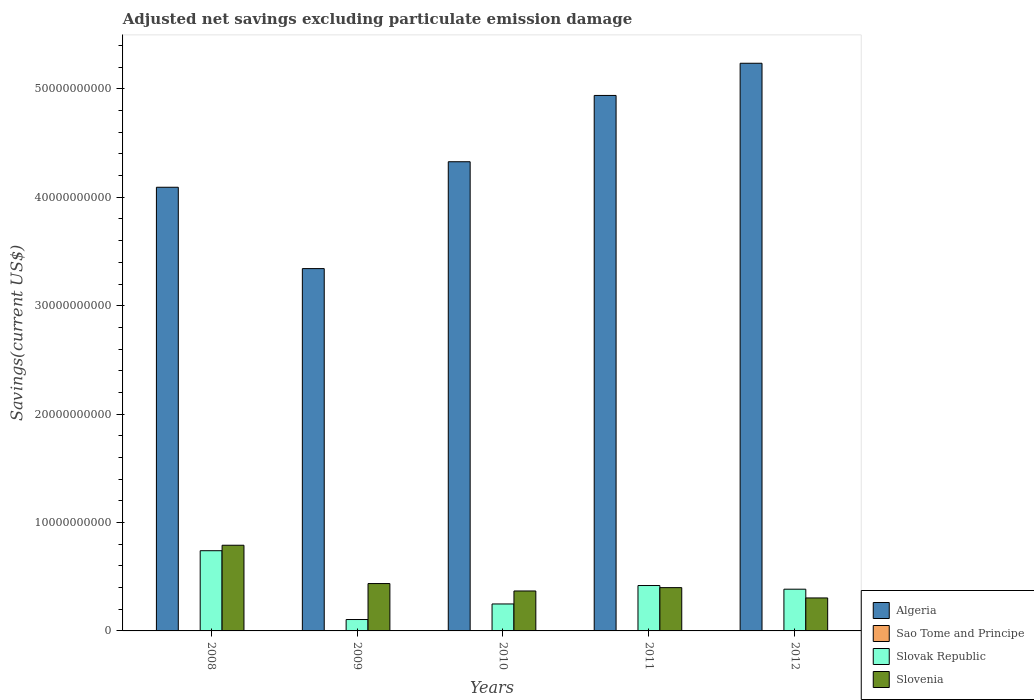Are the number of bars on each tick of the X-axis equal?
Offer a very short reply. No. How many bars are there on the 2nd tick from the left?
Ensure brevity in your answer.  4. What is the label of the 5th group of bars from the left?
Offer a terse response. 2012. In how many cases, is the number of bars for a given year not equal to the number of legend labels?
Your answer should be compact. 2. What is the adjusted net savings in Algeria in 2011?
Your answer should be compact. 4.94e+1. Across all years, what is the maximum adjusted net savings in Slovak Republic?
Offer a very short reply. 7.40e+09. Across all years, what is the minimum adjusted net savings in Slovak Republic?
Offer a terse response. 1.05e+09. What is the total adjusted net savings in Slovak Republic in the graph?
Your answer should be compact. 1.90e+1. What is the difference between the adjusted net savings in Slovenia in 2009 and that in 2012?
Provide a short and direct response. 1.33e+09. What is the difference between the adjusted net savings in Sao Tome and Principe in 2011 and the adjusted net savings in Slovak Republic in 2012?
Make the answer very short. -3.85e+09. What is the average adjusted net savings in Slovenia per year?
Make the answer very short. 4.60e+09. In the year 2008, what is the difference between the adjusted net savings in Slovenia and adjusted net savings in Slovak Republic?
Make the answer very short. 5.06e+08. What is the ratio of the adjusted net savings in Slovak Republic in 2011 to that in 2012?
Offer a very short reply. 1.09. Is the adjusted net savings in Algeria in 2008 less than that in 2010?
Keep it short and to the point. Yes. Is the difference between the adjusted net savings in Slovenia in 2008 and 2010 greater than the difference between the adjusted net savings in Slovak Republic in 2008 and 2010?
Provide a short and direct response. No. What is the difference between the highest and the second highest adjusted net savings in Slovak Republic?
Give a very brief answer. 3.21e+09. What is the difference between the highest and the lowest adjusted net savings in Algeria?
Your answer should be compact. 1.89e+1. Is the sum of the adjusted net savings in Slovak Republic in 2009 and 2011 greater than the maximum adjusted net savings in Sao Tome and Principe across all years?
Your answer should be compact. Yes. Is it the case that in every year, the sum of the adjusted net savings in Slovenia and adjusted net savings in Algeria is greater than the sum of adjusted net savings in Slovak Republic and adjusted net savings in Sao Tome and Principe?
Provide a short and direct response. Yes. Are all the bars in the graph horizontal?
Your answer should be compact. No. How many years are there in the graph?
Give a very brief answer. 5. Are the values on the major ticks of Y-axis written in scientific E-notation?
Keep it short and to the point. No. Does the graph contain any zero values?
Keep it short and to the point. Yes. Does the graph contain grids?
Make the answer very short. No. Where does the legend appear in the graph?
Provide a succinct answer. Bottom right. How many legend labels are there?
Offer a terse response. 4. What is the title of the graph?
Your answer should be very brief. Adjusted net savings excluding particulate emission damage. What is the label or title of the Y-axis?
Offer a very short reply. Savings(current US$). What is the Savings(current US$) of Algeria in 2008?
Make the answer very short. 4.09e+1. What is the Savings(current US$) of Slovak Republic in 2008?
Provide a short and direct response. 7.40e+09. What is the Savings(current US$) of Slovenia in 2008?
Your response must be concise. 7.90e+09. What is the Savings(current US$) in Algeria in 2009?
Offer a very short reply. 3.34e+1. What is the Savings(current US$) in Sao Tome and Principe in 2009?
Offer a terse response. 3.99e+05. What is the Savings(current US$) of Slovak Republic in 2009?
Make the answer very short. 1.05e+09. What is the Savings(current US$) of Slovenia in 2009?
Your answer should be very brief. 4.37e+09. What is the Savings(current US$) of Algeria in 2010?
Keep it short and to the point. 4.33e+1. What is the Savings(current US$) of Slovak Republic in 2010?
Offer a terse response. 2.49e+09. What is the Savings(current US$) of Slovenia in 2010?
Your answer should be compact. 3.69e+09. What is the Savings(current US$) in Algeria in 2011?
Offer a terse response. 4.94e+1. What is the Savings(current US$) in Sao Tome and Principe in 2011?
Offer a terse response. 6.00e+04. What is the Savings(current US$) of Slovak Republic in 2011?
Make the answer very short. 4.19e+09. What is the Savings(current US$) in Slovenia in 2011?
Your answer should be very brief. 3.99e+09. What is the Savings(current US$) in Algeria in 2012?
Your response must be concise. 5.24e+1. What is the Savings(current US$) in Sao Tome and Principe in 2012?
Ensure brevity in your answer.  1.08e+07. What is the Savings(current US$) of Slovak Republic in 2012?
Your answer should be very brief. 3.85e+09. What is the Savings(current US$) in Slovenia in 2012?
Offer a very short reply. 3.04e+09. Across all years, what is the maximum Savings(current US$) in Algeria?
Offer a very short reply. 5.24e+1. Across all years, what is the maximum Savings(current US$) of Sao Tome and Principe?
Offer a very short reply. 1.08e+07. Across all years, what is the maximum Savings(current US$) of Slovak Republic?
Make the answer very short. 7.40e+09. Across all years, what is the maximum Savings(current US$) of Slovenia?
Your response must be concise. 7.90e+09. Across all years, what is the minimum Savings(current US$) of Algeria?
Offer a terse response. 3.34e+1. Across all years, what is the minimum Savings(current US$) in Sao Tome and Principe?
Provide a short and direct response. 0. Across all years, what is the minimum Savings(current US$) in Slovak Republic?
Keep it short and to the point. 1.05e+09. Across all years, what is the minimum Savings(current US$) in Slovenia?
Your answer should be very brief. 3.04e+09. What is the total Savings(current US$) in Algeria in the graph?
Keep it short and to the point. 2.19e+11. What is the total Savings(current US$) of Sao Tome and Principe in the graph?
Your response must be concise. 1.13e+07. What is the total Savings(current US$) of Slovak Republic in the graph?
Your answer should be compact. 1.90e+1. What is the total Savings(current US$) of Slovenia in the graph?
Offer a very short reply. 2.30e+1. What is the difference between the Savings(current US$) in Algeria in 2008 and that in 2009?
Offer a terse response. 7.50e+09. What is the difference between the Savings(current US$) in Slovak Republic in 2008 and that in 2009?
Your answer should be very brief. 6.35e+09. What is the difference between the Savings(current US$) in Slovenia in 2008 and that in 2009?
Give a very brief answer. 3.53e+09. What is the difference between the Savings(current US$) in Algeria in 2008 and that in 2010?
Provide a succinct answer. -2.35e+09. What is the difference between the Savings(current US$) in Slovak Republic in 2008 and that in 2010?
Give a very brief answer. 4.91e+09. What is the difference between the Savings(current US$) in Slovenia in 2008 and that in 2010?
Keep it short and to the point. 4.22e+09. What is the difference between the Savings(current US$) in Algeria in 2008 and that in 2011?
Make the answer very short. -8.47e+09. What is the difference between the Savings(current US$) in Slovak Republic in 2008 and that in 2011?
Your answer should be compact. 3.21e+09. What is the difference between the Savings(current US$) of Slovenia in 2008 and that in 2011?
Give a very brief answer. 3.91e+09. What is the difference between the Savings(current US$) of Algeria in 2008 and that in 2012?
Offer a very short reply. -1.14e+1. What is the difference between the Savings(current US$) in Slovak Republic in 2008 and that in 2012?
Ensure brevity in your answer.  3.55e+09. What is the difference between the Savings(current US$) of Slovenia in 2008 and that in 2012?
Make the answer very short. 4.86e+09. What is the difference between the Savings(current US$) in Algeria in 2009 and that in 2010?
Ensure brevity in your answer.  -9.86e+09. What is the difference between the Savings(current US$) of Slovak Republic in 2009 and that in 2010?
Offer a terse response. -1.44e+09. What is the difference between the Savings(current US$) in Slovenia in 2009 and that in 2010?
Your response must be concise. 6.84e+08. What is the difference between the Savings(current US$) of Algeria in 2009 and that in 2011?
Keep it short and to the point. -1.60e+1. What is the difference between the Savings(current US$) in Sao Tome and Principe in 2009 and that in 2011?
Ensure brevity in your answer.  3.39e+05. What is the difference between the Savings(current US$) of Slovak Republic in 2009 and that in 2011?
Your response must be concise. -3.13e+09. What is the difference between the Savings(current US$) in Slovenia in 2009 and that in 2011?
Your answer should be compact. 3.77e+08. What is the difference between the Savings(current US$) of Algeria in 2009 and that in 2012?
Provide a short and direct response. -1.89e+1. What is the difference between the Savings(current US$) in Sao Tome and Principe in 2009 and that in 2012?
Your answer should be compact. -1.04e+07. What is the difference between the Savings(current US$) in Slovak Republic in 2009 and that in 2012?
Offer a terse response. -2.80e+09. What is the difference between the Savings(current US$) in Slovenia in 2009 and that in 2012?
Offer a terse response. 1.33e+09. What is the difference between the Savings(current US$) in Algeria in 2010 and that in 2011?
Ensure brevity in your answer.  -6.11e+09. What is the difference between the Savings(current US$) in Slovak Republic in 2010 and that in 2011?
Offer a terse response. -1.70e+09. What is the difference between the Savings(current US$) of Slovenia in 2010 and that in 2011?
Your response must be concise. -3.07e+08. What is the difference between the Savings(current US$) of Algeria in 2010 and that in 2012?
Make the answer very short. -9.08e+09. What is the difference between the Savings(current US$) in Slovak Republic in 2010 and that in 2012?
Keep it short and to the point. -1.36e+09. What is the difference between the Savings(current US$) of Slovenia in 2010 and that in 2012?
Give a very brief answer. 6.44e+08. What is the difference between the Savings(current US$) of Algeria in 2011 and that in 2012?
Provide a succinct answer. -2.97e+09. What is the difference between the Savings(current US$) in Sao Tome and Principe in 2011 and that in 2012?
Keep it short and to the point. -1.08e+07. What is the difference between the Savings(current US$) in Slovak Republic in 2011 and that in 2012?
Provide a succinct answer. 3.38e+08. What is the difference between the Savings(current US$) in Slovenia in 2011 and that in 2012?
Provide a succinct answer. 9.51e+08. What is the difference between the Savings(current US$) in Algeria in 2008 and the Savings(current US$) in Sao Tome and Principe in 2009?
Keep it short and to the point. 4.09e+1. What is the difference between the Savings(current US$) in Algeria in 2008 and the Savings(current US$) in Slovak Republic in 2009?
Ensure brevity in your answer.  3.99e+1. What is the difference between the Savings(current US$) in Algeria in 2008 and the Savings(current US$) in Slovenia in 2009?
Your answer should be very brief. 3.66e+1. What is the difference between the Savings(current US$) in Slovak Republic in 2008 and the Savings(current US$) in Slovenia in 2009?
Ensure brevity in your answer.  3.03e+09. What is the difference between the Savings(current US$) in Algeria in 2008 and the Savings(current US$) in Slovak Republic in 2010?
Your answer should be very brief. 3.84e+1. What is the difference between the Savings(current US$) of Algeria in 2008 and the Savings(current US$) of Slovenia in 2010?
Keep it short and to the point. 3.72e+1. What is the difference between the Savings(current US$) in Slovak Republic in 2008 and the Savings(current US$) in Slovenia in 2010?
Your answer should be compact. 3.71e+09. What is the difference between the Savings(current US$) in Algeria in 2008 and the Savings(current US$) in Sao Tome and Principe in 2011?
Make the answer very short. 4.09e+1. What is the difference between the Savings(current US$) in Algeria in 2008 and the Savings(current US$) in Slovak Republic in 2011?
Keep it short and to the point. 3.67e+1. What is the difference between the Savings(current US$) in Algeria in 2008 and the Savings(current US$) in Slovenia in 2011?
Provide a succinct answer. 3.69e+1. What is the difference between the Savings(current US$) of Slovak Republic in 2008 and the Savings(current US$) of Slovenia in 2011?
Provide a short and direct response. 3.41e+09. What is the difference between the Savings(current US$) in Algeria in 2008 and the Savings(current US$) in Sao Tome and Principe in 2012?
Offer a very short reply. 4.09e+1. What is the difference between the Savings(current US$) of Algeria in 2008 and the Savings(current US$) of Slovak Republic in 2012?
Your answer should be compact. 3.71e+1. What is the difference between the Savings(current US$) in Algeria in 2008 and the Savings(current US$) in Slovenia in 2012?
Your response must be concise. 3.79e+1. What is the difference between the Savings(current US$) of Slovak Republic in 2008 and the Savings(current US$) of Slovenia in 2012?
Offer a very short reply. 4.36e+09. What is the difference between the Savings(current US$) of Algeria in 2009 and the Savings(current US$) of Slovak Republic in 2010?
Provide a short and direct response. 3.09e+1. What is the difference between the Savings(current US$) in Algeria in 2009 and the Savings(current US$) in Slovenia in 2010?
Offer a very short reply. 2.97e+1. What is the difference between the Savings(current US$) of Sao Tome and Principe in 2009 and the Savings(current US$) of Slovak Republic in 2010?
Offer a terse response. -2.49e+09. What is the difference between the Savings(current US$) of Sao Tome and Principe in 2009 and the Savings(current US$) of Slovenia in 2010?
Offer a very short reply. -3.68e+09. What is the difference between the Savings(current US$) of Slovak Republic in 2009 and the Savings(current US$) of Slovenia in 2010?
Make the answer very short. -2.63e+09. What is the difference between the Savings(current US$) of Algeria in 2009 and the Savings(current US$) of Sao Tome and Principe in 2011?
Your answer should be very brief. 3.34e+1. What is the difference between the Savings(current US$) of Algeria in 2009 and the Savings(current US$) of Slovak Republic in 2011?
Make the answer very short. 2.92e+1. What is the difference between the Savings(current US$) in Algeria in 2009 and the Savings(current US$) in Slovenia in 2011?
Provide a succinct answer. 2.94e+1. What is the difference between the Savings(current US$) in Sao Tome and Principe in 2009 and the Savings(current US$) in Slovak Republic in 2011?
Offer a very short reply. -4.19e+09. What is the difference between the Savings(current US$) of Sao Tome and Principe in 2009 and the Savings(current US$) of Slovenia in 2011?
Your answer should be compact. -3.99e+09. What is the difference between the Savings(current US$) of Slovak Republic in 2009 and the Savings(current US$) of Slovenia in 2011?
Keep it short and to the point. -2.94e+09. What is the difference between the Savings(current US$) in Algeria in 2009 and the Savings(current US$) in Sao Tome and Principe in 2012?
Provide a succinct answer. 3.34e+1. What is the difference between the Savings(current US$) of Algeria in 2009 and the Savings(current US$) of Slovak Republic in 2012?
Keep it short and to the point. 2.96e+1. What is the difference between the Savings(current US$) of Algeria in 2009 and the Savings(current US$) of Slovenia in 2012?
Your response must be concise. 3.04e+1. What is the difference between the Savings(current US$) of Sao Tome and Principe in 2009 and the Savings(current US$) of Slovak Republic in 2012?
Your answer should be very brief. -3.85e+09. What is the difference between the Savings(current US$) in Sao Tome and Principe in 2009 and the Savings(current US$) in Slovenia in 2012?
Provide a succinct answer. -3.04e+09. What is the difference between the Savings(current US$) of Slovak Republic in 2009 and the Savings(current US$) of Slovenia in 2012?
Offer a terse response. -1.99e+09. What is the difference between the Savings(current US$) in Algeria in 2010 and the Savings(current US$) in Sao Tome and Principe in 2011?
Provide a succinct answer. 4.33e+1. What is the difference between the Savings(current US$) of Algeria in 2010 and the Savings(current US$) of Slovak Republic in 2011?
Offer a terse response. 3.91e+1. What is the difference between the Savings(current US$) of Algeria in 2010 and the Savings(current US$) of Slovenia in 2011?
Give a very brief answer. 3.93e+1. What is the difference between the Savings(current US$) in Slovak Republic in 2010 and the Savings(current US$) in Slovenia in 2011?
Provide a short and direct response. -1.51e+09. What is the difference between the Savings(current US$) in Algeria in 2010 and the Savings(current US$) in Sao Tome and Principe in 2012?
Ensure brevity in your answer.  4.33e+1. What is the difference between the Savings(current US$) in Algeria in 2010 and the Savings(current US$) in Slovak Republic in 2012?
Your answer should be compact. 3.94e+1. What is the difference between the Savings(current US$) in Algeria in 2010 and the Savings(current US$) in Slovenia in 2012?
Your answer should be compact. 4.02e+1. What is the difference between the Savings(current US$) of Slovak Republic in 2010 and the Savings(current US$) of Slovenia in 2012?
Make the answer very short. -5.54e+08. What is the difference between the Savings(current US$) in Algeria in 2011 and the Savings(current US$) in Sao Tome and Principe in 2012?
Ensure brevity in your answer.  4.94e+1. What is the difference between the Savings(current US$) in Algeria in 2011 and the Savings(current US$) in Slovak Republic in 2012?
Your answer should be very brief. 4.55e+1. What is the difference between the Savings(current US$) of Algeria in 2011 and the Savings(current US$) of Slovenia in 2012?
Make the answer very short. 4.64e+1. What is the difference between the Savings(current US$) of Sao Tome and Principe in 2011 and the Savings(current US$) of Slovak Republic in 2012?
Provide a short and direct response. -3.85e+09. What is the difference between the Savings(current US$) of Sao Tome and Principe in 2011 and the Savings(current US$) of Slovenia in 2012?
Your answer should be compact. -3.04e+09. What is the difference between the Savings(current US$) in Slovak Republic in 2011 and the Savings(current US$) in Slovenia in 2012?
Provide a succinct answer. 1.15e+09. What is the average Savings(current US$) of Algeria per year?
Keep it short and to the point. 4.39e+1. What is the average Savings(current US$) in Sao Tome and Principe per year?
Offer a terse response. 2.26e+06. What is the average Savings(current US$) of Slovak Republic per year?
Offer a very short reply. 3.79e+09. What is the average Savings(current US$) of Slovenia per year?
Offer a very short reply. 4.60e+09. In the year 2008, what is the difference between the Savings(current US$) of Algeria and Savings(current US$) of Slovak Republic?
Provide a short and direct response. 3.35e+1. In the year 2008, what is the difference between the Savings(current US$) of Algeria and Savings(current US$) of Slovenia?
Ensure brevity in your answer.  3.30e+1. In the year 2008, what is the difference between the Savings(current US$) in Slovak Republic and Savings(current US$) in Slovenia?
Your answer should be compact. -5.06e+08. In the year 2009, what is the difference between the Savings(current US$) in Algeria and Savings(current US$) in Sao Tome and Principe?
Your response must be concise. 3.34e+1. In the year 2009, what is the difference between the Savings(current US$) of Algeria and Savings(current US$) of Slovak Republic?
Provide a succinct answer. 3.24e+1. In the year 2009, what is the difference between the Savings(current US$) in Algeria and Savings(current US$) in Slovenia?
Provide a succinct answer. 2.91e+1. In the year 2009, what is the difference between the Savings(current US$) in Sao Tome and Principe and Savings(current US$) in Slovak Republic?
Make the answer very short. -1.05e+09. In the year 2009, what is the difference between the Savings(current US$) of Sao Tome and Principe and Savings(current US$) of Slovenia?
Offer a very short reply. -4.37e+09. In the year 2009, what is the difference between the Savings(current US$) of Slovak Republic and Savings(current US$) of Slovenia?
Offer a very short reply. -3.32e+09. In the year 2010, what is the difference between the Savings(current US$) in Algeria and Savings(current US$) in Slovak Republic?
Provide a succinct answer. 4.08e+1. In the year 2010, what is the difference between the Savings(current US$) in Algeria and Savings(current US$) in Slovenia?
Give a very brief answer. 3.96e+1. In the year 2010, what is the difference between the Savings(current US$) of Slovak Republic and Savings(current US$) of Slovenia?
Offer a very short reply. -1.20e+09. In the year 2011, what is the difference between the Savings(current US$) of Algeria and Savings(current US$) of Sao Tome and Principe?
Your answer should be very brief. 4.94e+1. In the year 2011, what is the difference between the Savings(current US$) in Algeria and Savings(current US$) in Slovak Republic?
Provide a short and direct response. 4.52e+1. In the year 2011, what is the difference between the Savings(current US$) in Algeria and Savings(current US$) in Slovenia?
Offer a very short reply. 4.54e+1. In the year 2011, what is the difference between the Savings(current US$) in Sao Tome and Principe and Savings(current US$) in Slovak Republic?
Offer a terse response. -4.19e+09. In the year 2011, what is the difference between the Savings(current US$) of Sao Tome and Principe and Savings(current US$) of Slovenia?
Your answer should be very brief. -3.99e+09. In the year 2011, what is the difference between the Savings(current US$) of Slovak Republic and Savings(current US$) of Slovenia?
Your response must be concise. 1.94e+08. In the year 2012, what is the difference between the Savings(current US$) of Algeria and Savings(current US$) of Sao Tome and Principe?
Provide a short and direct response. 5.24e+1. In the year 2012, what is the difference between the Savings(current US$) in Algeria and Savings(current US$) in Slovak Republic?
Your response must be concise. 4.85e+1. In the year 2012, what is the difference between the Savings(current US$) in Algeria and Savings(current US$) in Slovenia?
Provide a succinct answer. 4.93e+1. In the year 2012, what is the difference between the Savings(current US$) of Sao Tome and Principe and Savings(current US$) of Slovak Republic?
Ensure brevity in your answer.  -3.84e+09. In the year 2012, what is the difference between the Savings(current US$) of Sao Tome and Principe and Savings(current US$) of Slovenia?
Your answer should be compact. -3.03e+09. In the year 2012, what is the difference between the Savings(current US$) in Slovak Republic and Savings(current US$) in Slovenia?
Provide a short and direct response. 8.07e+08. What is the ratio of the Savings(current US$) in Algeria in 2008 to that in 2009?
Provide a short and direct response. 1.22. What is the ratio of the Savings(current US$) of Slovak Republic in 2008 to that in 2009?
Offer a very short reply. 7.03. What is the ratio of the Savings(current US$) in Slovenia in 2008 to that in 2009?
Your response must be concise. 1.81. What is the ratio of the Savings(current US$) in Algeria in 2008 to that in 2010?
Keep it short and to the point. 0.95. What is the ratio of the Savings(current US$) in Slovak Republic in 2008 to that in 2010?
Make the answer very short. 2.97. What is the ratio of the Savings(current US$) of Slovenia in 2008 to that in 2010?
Make the answer very short. 2.14. What is the ratio of the Savings(current US$) of Algeria in 2008 to that in 2011?
Give a very brief answer. 0.83. What is the ratio of the Savings(current US$) in Slovak Republic in 2008 to that in 2011?
Your answer should be compact. 1.77. What is the ratio of the Savings(current US$) of Slovenia in 2008 to that in 2011?
Provide a short and direct response. 1.98. What is the ratio of the Savings(current US$) of Algeria in 2008 to that in 2012?
Provide a succinct answer. 0.78. What is the ratio of the Savings(current US$) of Slovak Republic in 2008 to that in 2012?
Offer a terse response. 1.92. What is the ratio of the Savings(current US$) in Slovenia in 2008 to that in 2012?
Provide a succinct answer. 2.6. What is the ratio of the Savings(current US$) in Algeria in 2009 to that in 2010?
Offer a very short reply. 0.77. What is the ratio of the Savings(current US$) of Slovak Republic in 2009 to that in 2010?
Your answer should be very brief. 0.42. What is the ratio of the Savings(current US$) in Slovenia in 2009 to that in 2010?
Ensure brevity in your answer.  1.19. What is the ratio of the Savings(current US$) in Algeria in 2009 to that in 2011?
Keep it short and to the point. 0.68. What is the ratio of the Savings(current US$) of Sao Tome and Principe in 2009 to that in 2011?
Your answer should be very brief. 6.65. What is the ratio of the Savings(current US$) in Slovak Republic in 2009 to that in 2011?
Provide a succinct answer. 0.25. What is the ratio of the Savings(current US$) of Slovenia in 2009 to that in 2011?
Offer a very short reply. 1.09. What is the ratio of the Savings(current US$) in Algeria in 2009 to that in 2012?
Provide a succinct answer. 0.64. What is the ratio of the Savings(current US$) in Sao Tome and Principe in 2009 to that in 2012?
Give a very brief answer. 0.04. What is the ratio of the Savings(current US$) of Slovak Republic in 2009 to that in 2012?
Offer a very short reply. 0.27. What is the ratio of the Savings(current US$) of Slovenia in 2009 to that in 2012?
Provide a succinct answer. 1.44. What is the ratio of the Savings(current US$) of Algeria in 2010 to that in 2011?
Offer a very short reply. 0.88. What is the ratio of the Savings(current US$) of Slovak Republic in 2010 to that in 2011?
Your response must be concise. 0.59. What is the ratio of the Savings(current US$) of Slovenia in 2010 to that in 2011?
Your answer should be very brief. 0.92. What is the ratio of the Savings(current US$) in Algeria in 2010 to that in 2012?
Your answer should be compact. 0.83. What is the ratio of the Savings(current US$) of Slovak Republic in 2010 to that in 2012?
Provide a succinct answer. 0.65. What is the ratio of the Savings(current US$) of Slovenia in 2010 to that in 2012?
Give a very brief answer. 1.21. What is the ratio of the Savings(current US$) of Algeria in 2011 to that in 2012?
Your response must be concise. 0.94. What is the ratio of the Savings(current US$) in Sao Tome and Principe in 2011 to that in 2012?
Offer a terse response. 0.01. What is the ratio of the Savings(current US$) in Slovak Republic in 2011 to that in 2012?
Provide a succinct answer. 1.09. What is the ratio of the Savings(current US$) in Slovenia in 2011 to that in 2012?
Offer a terse response. 1.31. What is the difference between the highest and the second highest Savings(current US$) of Algeria?
Offer a very short reply. 2.97e+09. What is the difference between the highest and the second highest Savings(current US$) in Sao Tome and Principe?
Your answer should be compact. 1.04e+07. What is the difference between the highest and the second highest Savings(current US$) of Slovak Republic?
Offer a very short reply. 3.21e+09. What is the difference between the highest and the second highest Savings(current US$) in Slovenia?
Your answer should be compact. 3.53e+09. What is the difference between the highest and the lowest Savings(current US$) in Algeria?
Offer a very short reply. 1.89e+1. What is the difference between the highest and the lowest Savings(current US$) in Sao Tome and Principe?
Keep it short and to the point. 1.08e+07. What is the difference between the highest and the lowest Savings(current US$) in Slovak Republic?
Provide a succinct answer. 6.35e+09. What is the difference between the highest and the lowest Savings(current US$) of Slovenia?
Make the answer very short. 4.86e+09. 